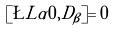<formula> <loc_0><loc_0><loc_500><loc_500>[ \L L \alpha { 0 } , \tilde { D } _ { \beta } ] = 0</formula> 